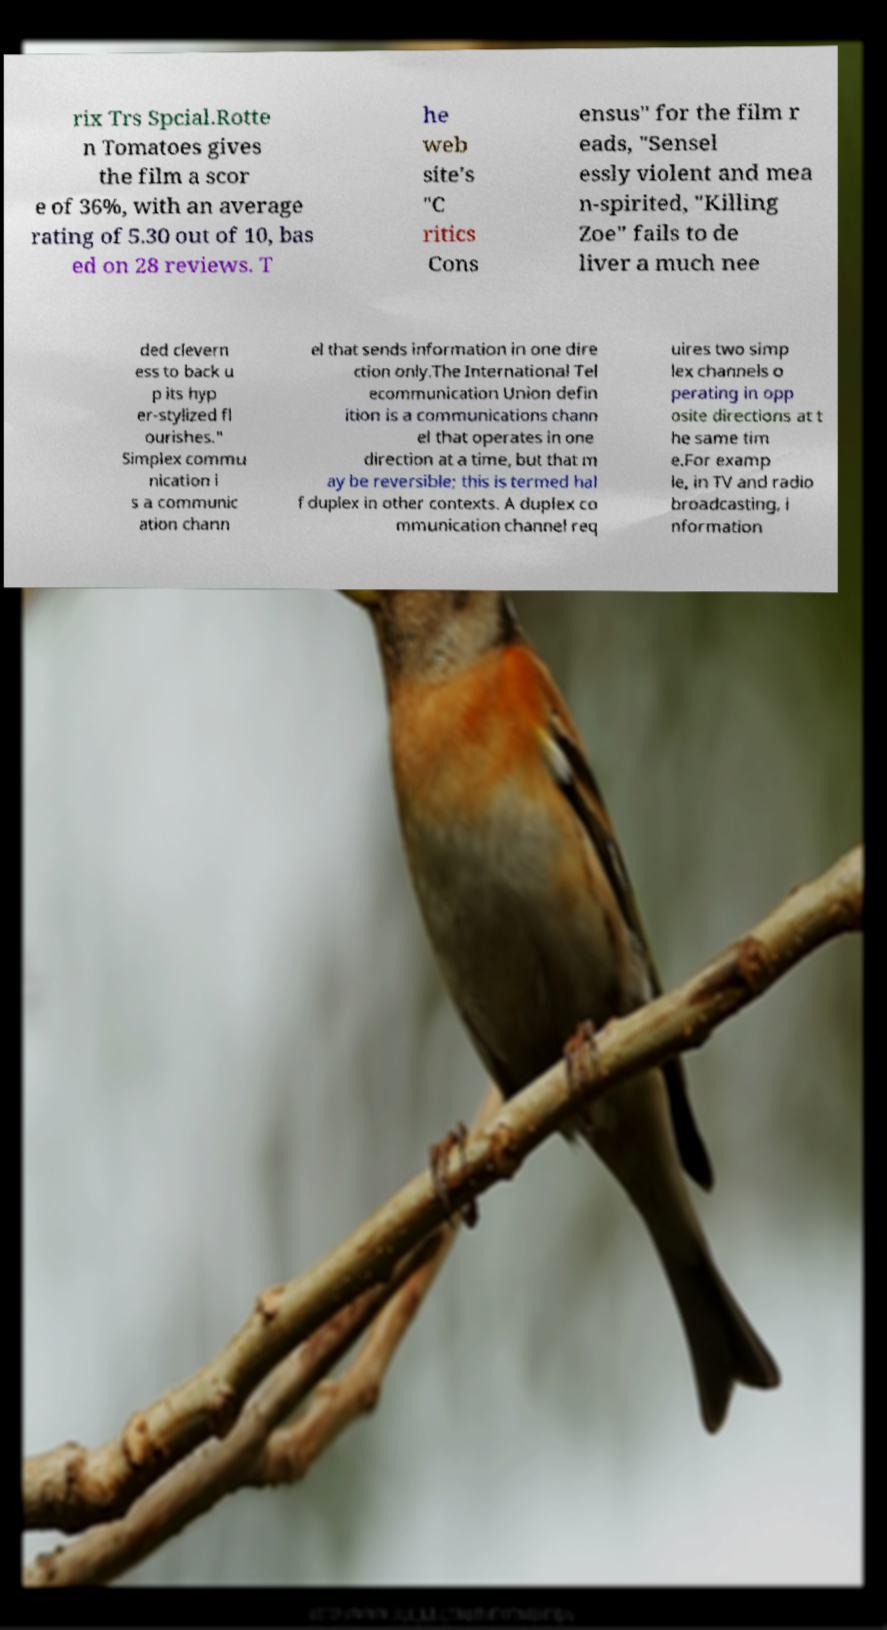For documentation purposes, I need the text within this image transcribed. Could you provide that? rix Trs Spcial.Rotte n Tomatoes gives the film a scor e of 36%, with an average rating of 5.30 out of 10, bas ed on 28 reviews. T he web site's "C ritics Cons ensus" for the film r eads, "Sensel essly violent and mea n-spirited, "Killing Zoe" fails to de liver a much nee ded clevern ess to back u p its hyp er-stylized fl ourishes." Simplex commu nication i s a communic ation chann el that sends information in one dire ction only.The International Tel ecommunication Union defin ition is a communications chann el that operates in one direction at a time, but that m ay be reversible; this is termed hal f duplex in other contexts. A duplex co mmunication channel req uires two simp lex channels o perating in opp osite directions at t he same tim e.For examp le, in TV and radio broadcasting, i nformation 